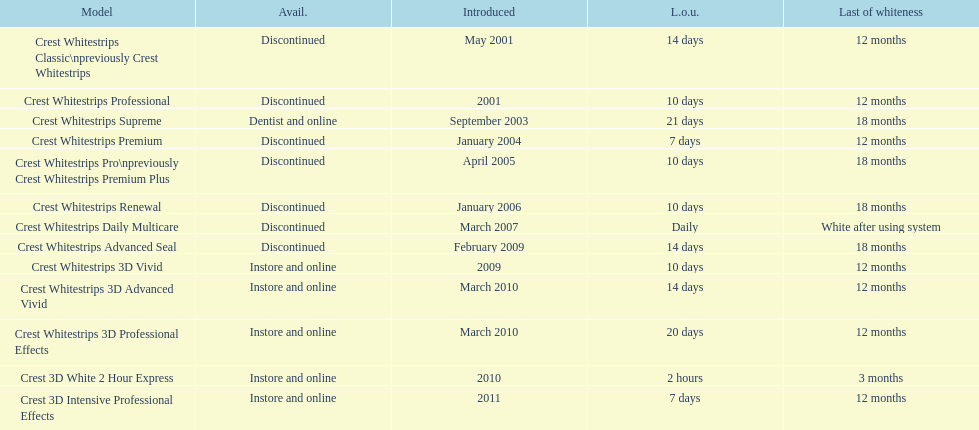Does the crest white strips pro last as long as the crest white strips renewal? Yes. 